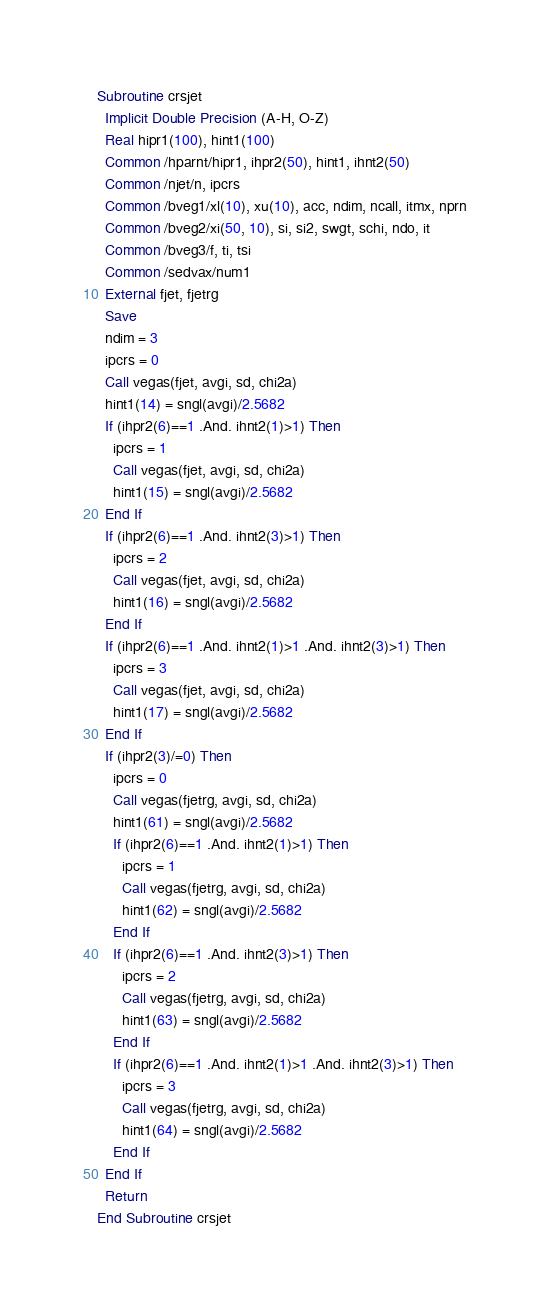Convert code to text. <code><loc_0><loc_0><loc_500><loc_500><_FORTRAN_>Subroutine crsjet
  Implicit Double Precision (A-H, O-Z)
  Real hipr1(100), hint1(100)
  Common /hparnt/hipr1, ihpr2(50), hint1, ihnt2(50)
  Common /njet/n, ipcrs
  Common /bveg1/xl(10), xu(10), acc, ndim, ncall, itmx, nprn
  Common /bveg2/xi(50, 10), si, si2, swgt, schi, ndo, it
  Common /bveg3/f, ti, tsi
  Common /sedvax/num1
  External fjet, fjetrg
  Save
  ndim = 3
  ipcrs = 0
  Call vegas(fjet, avgi, sd, chi2a)
  hint1(14) = sngl(avgi)/2.5682
  If (ihpr2(6)==1 .And. ihnt2(1)>1) Then
    ipcrs = 1
    Call vegas(fjet, avgi, sd, chi2a)
    hint1(15) = sngl(avgi)/2.5682
  End If
  If (ihpr2(6)==1 .And. ihnt2(3)>1) Then
    ipcrs = 2
    Call vegas(fjet, avgi, sd, chi2a)
    hint1(16) = sngl(avgi)/2.5682
  End If
  If (ihpr2(6)==1 .And. ihnt2(1)>1 .And. ihnt2(3)>1) Then
    ipcrs = 3
    Call vegas(fjet, avgi, sd, chi2a)
    hint1(17) = sngl(avgi)/2.5682
  End If
  If (ihpr2(3)/=0) Then
    ipcrs = 0
    Call vegas(fjetrg, avgi, sd, chi2a)
    hint1(61) = sngl(avgi)/2.5682
    If (ihpr2(6)==1 .And. ihnt2(1)>1) Then
      ipcrs = 1
      Call vegas(fjetrg, avgi, sd, chi2a)
      hint1(62) = sngl(avgi)/2.5682
    End If
    If (ihpr2(6)==1 .And. ihnt2(3)>1) Then
      ipcrs = 2
      Call vegas(fjetrg, avgi, sd, chi2a)
      hint1(63) = sngl(avgi)/2.5682
    End If
    If (ihpr2(6)==1 .And. ihnt2(1)>1 .And. ihnt2(3)>1) Then
      ipcrs = 3
      Call vegas(fjetrg, avgi, sd, chi2a)
      hint1(64) = sngl(avgi)/2.5682
    End If
  End If
  Return
End Subroutine crsjet
</code> 